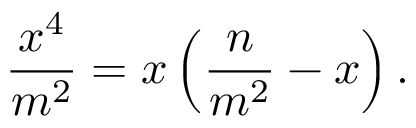<formula> <loc_0><loc_0><loc_500><loc_500>{ \frac { x ^ { 4 } } { m ^ { 2 } } } = x \left ( { \frac { n } { m ^ { 2 } } } - x \right ) .</formula> 